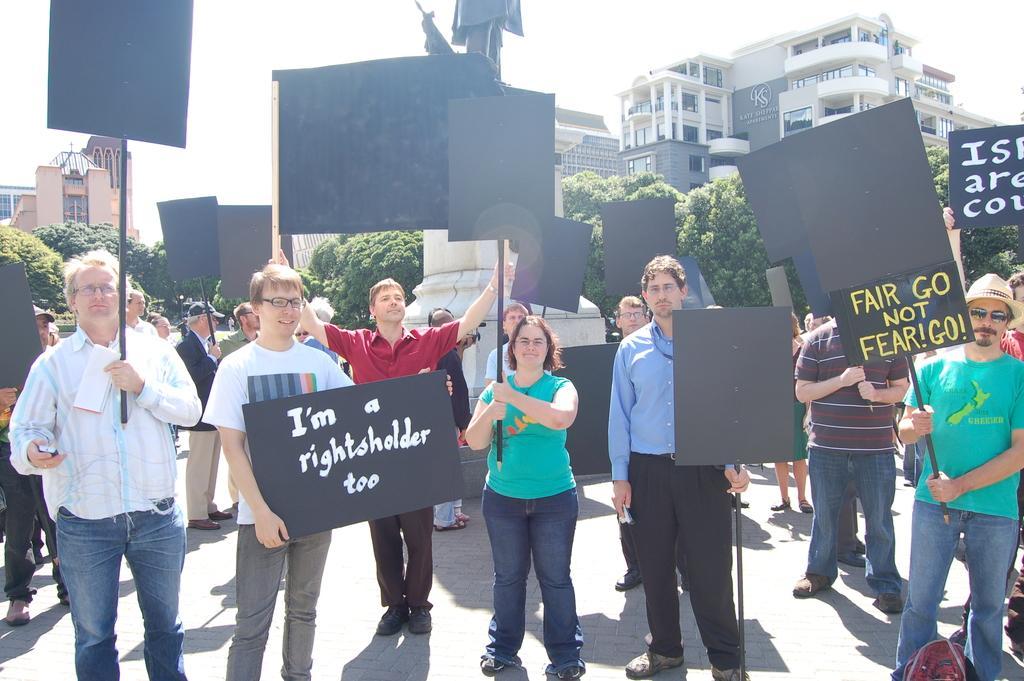In one or two sentences, can you explain what this image depicts? In the center of the image we can see people standing and holding boards in their hands. In the background there are trees, buildings and sky. 